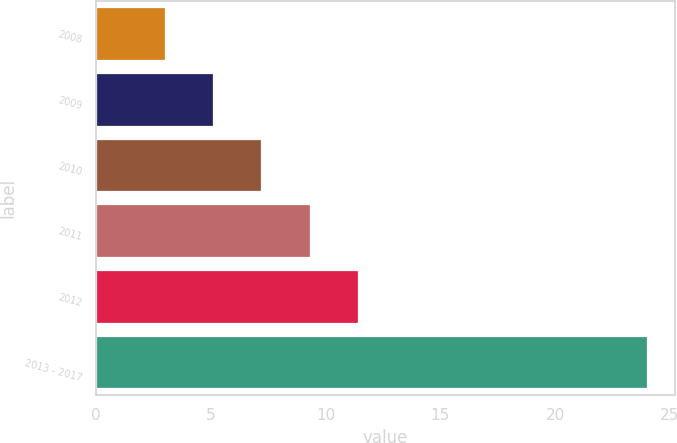<chart> <loc_0><loc_0><loc_500><loc_500><bar_chart><fcel>2008<fcel>2009<fcel>2010<fcel>2011<fcel>2012<fcel>2013 - 2017<nl><fcel>3<fcel>5.1<fcel>7.2<fcel>9.3<fcel>11.4<fcel>24<nl></chart> 